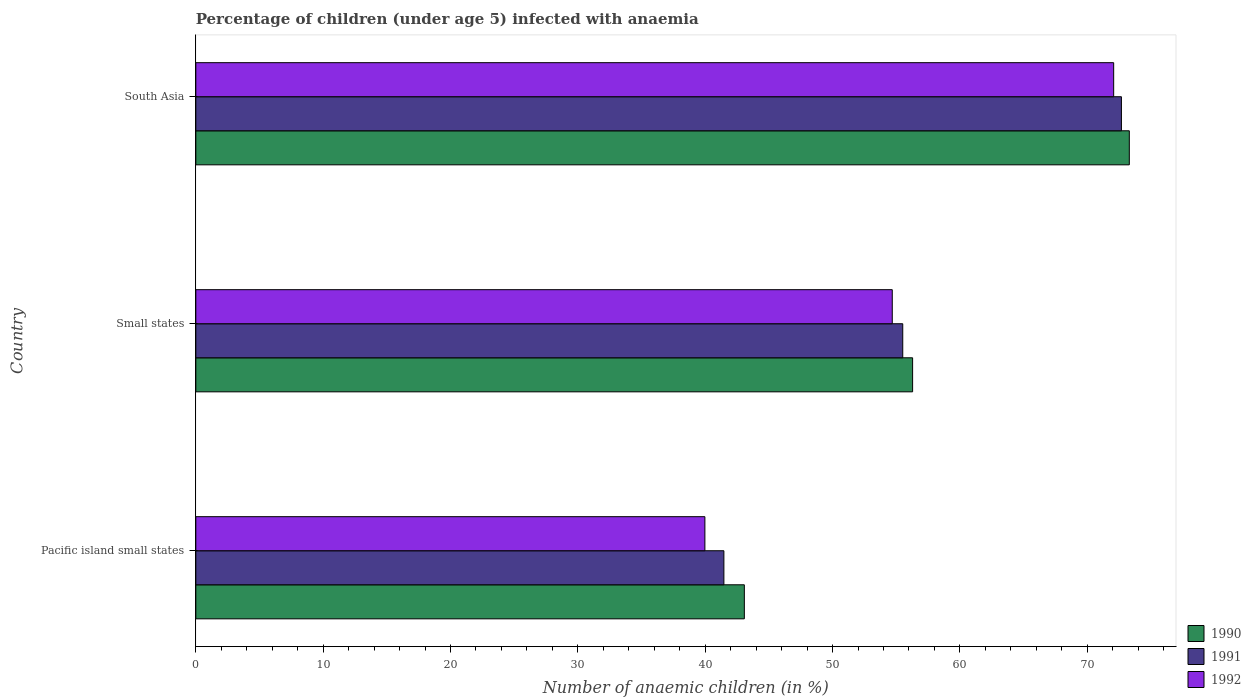Are the number of bars per tick equal to the number of legend labels?
Your answer should be very brief. Yes. How many bars are there on the 2nd tick from the top?
Ensure brevity in your answer.  3. What is the label of the 3rd group of bars from the top?
Offer a very short reply. Pacific island small states. What is the percentage of children infected with anaemia in in 1990 in Pacific island small states?
Provide a short and direct response. 43.07. Across all countries, what is the maximum percentage of children infected with anaemia in in 1992?
Ensure brevity in your answer.  72.08. Across all countries, what is the minimum percentage of children infected with anaemia in in 1992?
Keep it short and to the point. 39.98. In which country was the percentage of children infected with anaemia in in 1992 maximum?
Your answer should be compact. South Asia. In which country was the percentage of children infected with anaemia in in 1992 minimum?
Your answer should be very brief. Pacific island small states. What is the total percentage of children infected with anaemia in in 1990 in the graph?
Offer a terse response. 172.67. What is the difference between the percentage of children infected with anaemia in in 1991 in Small states and that in South Asia?
Give a very brief answer. -17.17. What is the difference between the percentage of children infected with anaemia in in 1992 in South Asia and the percentage of children infected with anaemia in in 1990 in Pacific island small states?
Give a very brief answer. 29. What is the average percentage of children infected with anaemia in in 1992 per country?
Your answer should be compact. 55.58. What is the difference between the percentage of children infected with anaemia in in 1992 and percentage of children infected with anaemia in in 1991 in Pacific island small states?
Give a very brief answer. -1.49. In how many countries, is the percentage of children infected with anaemia in in 1991 greater than 56 %?
Provide a succinct answer. 1. What is the ratio of the percentage of children infected with anaemia in in 1990 in Pacific island small states to that in South Asia?
Ensure brevity in your answer.  0.59. Is the percentage of children infected with anaemia in in 1991 in Small states less than that in South Asia?
Provide a short and direct response. Yes. Is the difference between the percentage of children infected with anaemia in in 1992 in Pacific island small states and Small states greater than the difference between the percentage of children infected with anaemia in in 1991 in Pacific island small states and Small states?
Ensure brevity in your answer.  No. What is the difference between the highest and the second highest percentage of children infected with anaemia in in 1992?
Provide a short and direct response. 17.39. What is the difference between the highest and the lowest percentage of children infected with anaemia in in 1990?
Your answer should be compact. 30.23. What does the 2nd bar from the bottom in Small states represents?
Keep it short and to the point. 1991. Are the values on the major ticks of X-axis written in scientific E-notation?
Provide a short and direct response. No. Does the graph contain grids?
Provide a succinct answer. No. How many legend labels are there?
Offer a very short reply. 3. How are the legend labels stacked?
Give a very brief answer. Vertical. What is the title of the graph?
Ensure brevity in your answer.  Percentage of children (under age 5) infected with anaemia. Does "1981" appear as one of the legend labels in the graph?
Give a very brief answer. No. What is the label or title of the X-axis?
Provide a short and direct response. Number of anaemic children (in %). What is the Number of anaemic children (in %) in 1990 in Pacific island small states?
Provide a short and direct response. 43.07. What is the Number of anaemic children (in %) in 1991 in Pacific island small states?
Offer a terse response. 41.47. What is the Number of anaemic children (in %) in 1992 in Pacific island small states?
Offer a very short reply. 39.98. What is the Number of anaemic children (in %) in 1990 in Small states?
Offer a very short reply. 56.29. What is the Number of anaemic children (in %) of 1991 in Small states?
Provide a short and direct response. 55.51. What is the Number of anaemic children (in %) of 1992 in Small states?
Provide a succinct answer. 54.69. What is the Number of anaemic children (in %) in 1990 in South Asia?
Your answer should be compact. 73.3. What is the Number of anaemic children (in %) in 1991 in South Asia?
Provide a short and direct response. 72.68. What is the Number of anaemic children (in %) of 1992 in South Asia?
Give a very brief answer. 72.08. Across all countries, what is the maximum Number of anaemic children (in %) of 1990?
Give a very brief answer. 73.3. Across all countries, what is the maximum Number of anaemic children (in %) in 1991?
Offer a terse response. 72.68. Across all countries, what is the maximum Number of anaemic children (in %) of 1992?
Provide a short and direct response. 72.08. Across all countries, what is the minimum Number of anaemic children (in %) in 1990?
Offer a terse response. 43.07. Across all countries, what is the minimum Number of anaemic children (in %) of 1991?
Offer a terse response. 41.47. Across all countries, what is the minimum Number of anaemic children (in %) in 1992?
Offer a terse response. 39.98. What is the total Number of anaemic children (in %) in 1990 in the graph?
Offer a terse response. 172.67. What is the total Number of anaemic children (in %) of 1991 in the graph?
Offer a terse response. 169.66. What is the total Number of anaemic children (in %) in 1992 in the graph?
Provide a succinct answer. 166.74. What is the difference between the Number of anaemic children (in %) in 1990 in Pacific island small states and that in Small states?
Provide a short and direct response. -13.21. What is the difference between the Number of anaemic children (in %) of 1991 in Pacific island small states and that in Small states?
Provide a short and direct response. -14.05. What is the difference between the Number of anaemic children (in %) of 1992 in Pacific island small states and that in Small states?
Give a very brief answer. -14.71. What is the difference between the Number of anaemic children (in %) of 1990 in Pacific island small states and that in South Asia?
Keep it short and to the point. -30.23. What is the difference between the Number of anaemic children (in %) in 1991 in Pacific island small states and that in South Asia?
Give a very brief answer. -31.22. What is the difference between the Number of anaemic children (in %) in 1992 in Pacific island small states and that in South Asia?
Give a very brief answer. -32.1. What is the difference between the Number of anaemic children (in %) in 1990 in Small states and that in South Asia?
Make the answer very short. -17.02. What is the difference between the Number of anaemic children (in %) of 1991 in Small states and that in South Asia?
Keep it short and to the point. -17.17. What is the difference between the Number of anaemic children (in %) of 1992 in Small states and that in South Asia?
Offer a terse response. -17.39. What is the difference between the Number of anaemic children (in %) of 1990 in Pacific island small states and the Number of anaemic children (in %) of 1991 in Small states?
Give a very brief answer. -12.44. What is the difference between the Number of anaemic children (in %) of 1990 in Pacific island small states and the Number of anaemic children (in %) of 1992 in Small states?
Provide a short and direct response. -11.61. What is the difference between the Number of anaemic children (in %) of 1991 in Pacific island small states and the Number of anaemic children (in %) of 1992 in Small states?
Offer a terse response. -13.22. What is the difference between the Number of anaemic children (in %) of 1990 in Pacific island small states and the Number of anaemic children (in %) of 1991 in South Asia?
Your answer should be very brief. -29.61. What is the difference between the Number of anaemic children (in %) of 1990 in Pacific island small states and the Number of anaemic children (in %) of 1992 in South Asia?
Give a very brief answer. -29. What is the difference between the Number of anaemic children (in %) of 1991 in Pacific island small states and the Number of anaemic children (in %) of 1992 in South Asia?
Offer a terse response. -30.61. What is the difference between the Number of anaemic children (in %) of 1990 in Small states and the Number of anaemic children (in %) of 1991 in South Asia?
Ensure brevity in your answer.  -16.4. What is the difference between the Number of anaemic children (in %) of 1990 in Small states and the Number of anaemic children (in %) of 1992 in South Asia?
Ensure brevity in your answer.  -15.79. What is the difference between the Number of anaemic children (in %) in 1991 in Small states and the Number of anaemic children (in %) in 1992 in South Asia?
Give a very brief answer. -16.56. What is the average Number of anaemic children (in %) in 1990 per country?
Your answer should be very brief. 57.56. What is the average Number of anaemic children (in %) of 1991 per country?
Make the answer very short. 56.55. What is the average Number of anaemic children (in %) in 1992 per country?
Make the answer very short. 55.58. What is the difference between the Number of anaemic children (in %) of 1990 and Number of anaemic children (in %) of 1991 in Pacific island small states?
Make the answer very short. 1.61. What is the difference between the Number of anaemic children (in %) of 1990 and Number of anaemic children (in %) of 1992 in Pacific island small states?
Your answer should be compact. 3.1. What is the difference between the Number of anaemic children (in %) of 1991 and Number of anaemic children (in %) of 1992 in Pacific island small states?
Your answer should be compact. 1.49. What is the difference between the Number of anaemic children (in %) in 1990 and Number of anaemic children (in %) in 1991 in Small states?
Provide a succinct answer. 0.77. What is the difference between the Number of anaemic children (in %) in 1990 and Number of anaemic children (in %) in 1992 in Small states?
Keep it short and to the point. 1.6. What is the difference between the Number of anaemic children (in %) in 1991 and Number of anaemic children (in %) in 1992 in Small states?
Offer a terse response. 0.82. What is the difference between the Number of anaemic children (in %) of 1990 and Number of anaemic children (in %) of 1991 in South Asia?
Provide a succinct answer. 0.62. What is the difference between the Number of anaemic children (in %) in 1990 and Number of anaemic children (in %) in 1992 in South Asia?
Give a very brief answer. 1.23. What is the difference between the Number of anaemic children (in %) of 1991 and Number of anaemic children (in %) of 1992 in South Asia?
Your answer should be compact. 0.61. What is the ratio of the Number of anaemic children (in %) in 1990 in Pacific island small states to that in Small states?
Your response must be concise. 0.77. What is the ratio of the Number of anaemic children (in %) in 1991 in Pacific island small states to that in Small states?
Offer a very short reply. 0.75. What is the ratio of the Number of anaemic children (in %) of 1992 in Pacific island small states to that in Small states?
Provide a succinct answer. 0.73. What is the ratio of the Number of anaemic children (in %) in 1990 in Pacific island small states to that in South Asia?
Your answer should be compact. 0.59. What is the ratio of the Number of anaemic children (in %) of 1991 in Pacific island small states to that in South Asia?
Ensure brevity in your answer.  0.57. What is the ratio of the Number of anaemic children (in %) of 1992 in Pacific island small states to that in South Asia?
Make the answer very short. 0.55. What is the ratio of the Number of anaemic children (in %) in 1990 in Small states to that in South Asia?
Your answer should be very brief. 0.77. What is the ratio of the Number of anaemic children (in %) in 1991 in Small states to that in South Asia?
Ensure brevity in your answer.  0.76. What is the ratio of the Number of anaemic children (in %) in 1992 in Small states to that in South Asia?
Give a very brief answer. 0.76. What is the difference between the highest and the second highest Number of anaemic children (in %) in 1990?
Ensure brevity in your answer.  17.02. What is the difference between the highest and the second highest Number of anaemic children (in %) in 1991?
Keep it short and to the point. 17.17. What is the difference between the highest and the second highest Number of anaemic children (in %) in 1992?
Offer a very short reply. 17.39. What is the difference between the highest and the lowest Number of anaemic children (in %) of 1990?
Offer a very short reply. 30.23. What is the difference between the highest and the lowest Number of anaemic children (in %) in 1991?
Your answer should be very brief. 31.22. What is the difference between the highest and the lowest Number of anaemic children (in %) of 1992?
Ensure brevity in your answer.  32.1. 